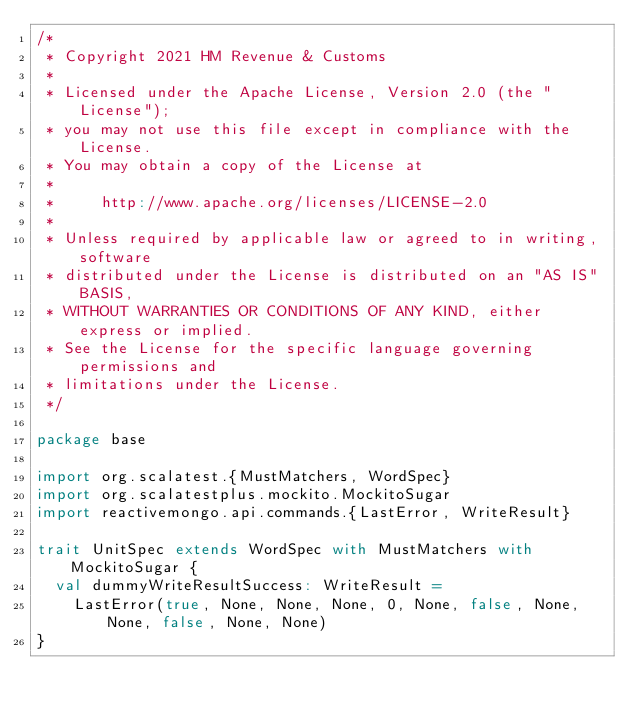Convert code to text. <code><loc_0><loc_0><loc_500><loc_500><_Scala_>/*
 * Copyright 2021 HM Revenue & Customs
 *
 * Licensed under the Apache License, Version 2.0 (the "License");
 * you may not use this file except in compliance with the License.
 * You may obtain a copy of the License at
 *
 *     http://www.apache.org/licenses/LICENSE-2.0
 *
 * Unless required by applicable law or agreed to in writing, software
 * distributed under the License is distributed on an "AS IS" BASIS,
 * WITHOUT WARRANTIES OR CONDITIONS OF ANY KIND, either express or implied.
 * See the License for the specific language governing permissions and
 * limitations under the License.
 */

package base

import org.scalatest.{MustMatchers, WordSpec}
import org.scalatestplus.mockito.MockitoSugar
import reactivemongo.api.commands.{LastError, WriteResult}

trait UnitSpec extends WordSpec with MustMatchers with MockitoSugar {
  val dummyWriteResultSuccess: WriteResult =
    LastError(true, None, None, None, 0, None, false, None, None, false, None, None)
}
</code> 